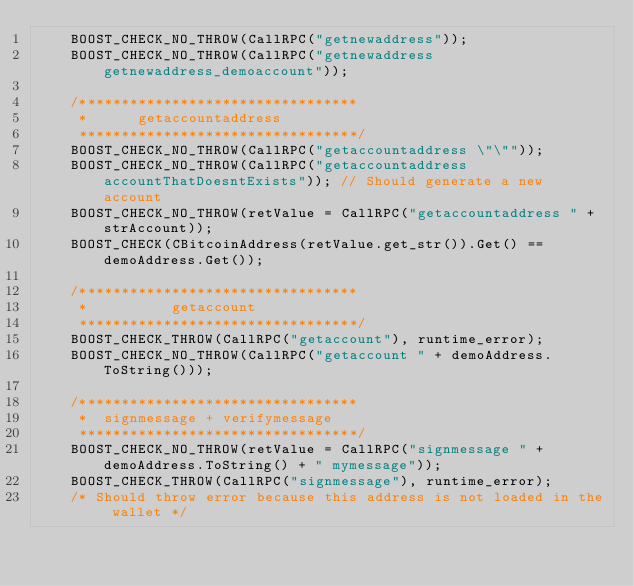<code> <loc_0><loc_0><loc_500><loc_500><_C++_>    BOOST_CHECK_NO_THROW(CallRPC("getnewaddress"));
    BOOST_CHECK_NO_THROW(CallRPC("getnewaddress getnewaddress_demoaccount"));

    /*********************************
     * 		getaccountaddress
     *********************************/
    BOOST_CHECK_NO_THROW(CallRPC("getaccountaddress \"\""));
    BOOST_CHECK_NO_THROW(CallRPC("getaccountaddress accountThatDoesntExists")); // Should generate a new account
    BOOST_CHECK_NO_THROW(retValue = CallRPC("getaccountaddress " + strAccount));
    BOOST_CHECK(CBitcoinAddress(retValue.get_str()).Get() == demoAddress.Get());

    /*********************************
     * 			getaccount
     *********************************/
    BOOST_CHECK_THROW(CallRPC("getaccount"), runtime_error);
    BOOST_CHECK_NO_THROW(CallRPC("getaccount " + demoAddress.ToString()));

    /*********************************
     * 	signmessage + verifymessage
     *********************************/
    BOOST_CHECK_NO_THROW(retValue = CallRPC("signmessage " + demoAddress.ToString() + " mymessage"));
    BOOST_CHECK_THROW(CallRPC("signmessage"), runtime_error);
    /* Should throw error because this address is not loaded in the wallet */</code> 